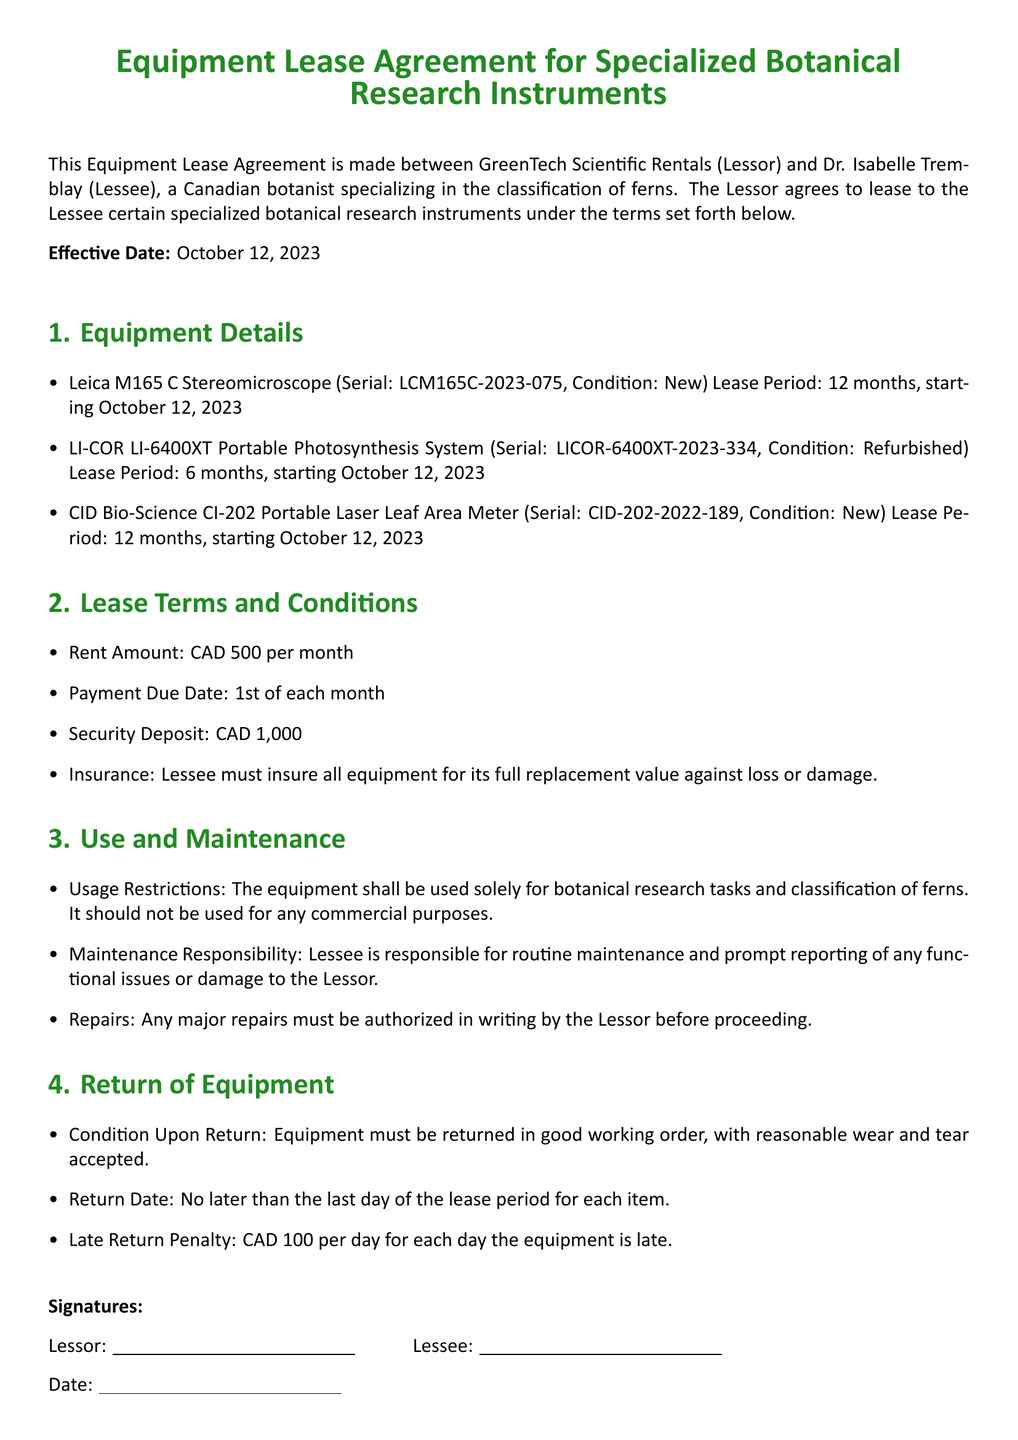What is the effective date of the lease agreement? The effective date is stated at the beginning of the document.
Answer: October 12, 2023 Who is the Lessee in this agreement? The Lessee's name is specified under the parties involved in the lease.
Answer: Dr. Isabelle Tremblay What is the monthly rent amount for the leased equipment? The rent amount is outlined under the lease terms and conditions.
Answer: CAD 500 How long is the lease period for the Leica M165 C Stereomicroscope? The lease period is noted in the equipment details section for this specific equipment.
Answer: 12 months What is the security deposit amount required? The amount for the security deposit is specifically stated in the lease terms.
Answer: CAD 1,000 What is the penalty for late return of equipment? The penalty for late return is outlined in the return of equipment section.
Answer: CAD 100 per day What is the condition of the equipment upon return? The condition requirement for returning the equipment is specified in the return of equipment section.
Answer: Good working order What type of research tasks can the equipment be used for? The allowed use for the equipment is detailed in the use and maintenance section.
Answer: Botanical research tasks What is the insurance requirement for the Lessee? The insurance requirement is specified under the lease terms and conditions section.
Answer: Insure for full replacement value 